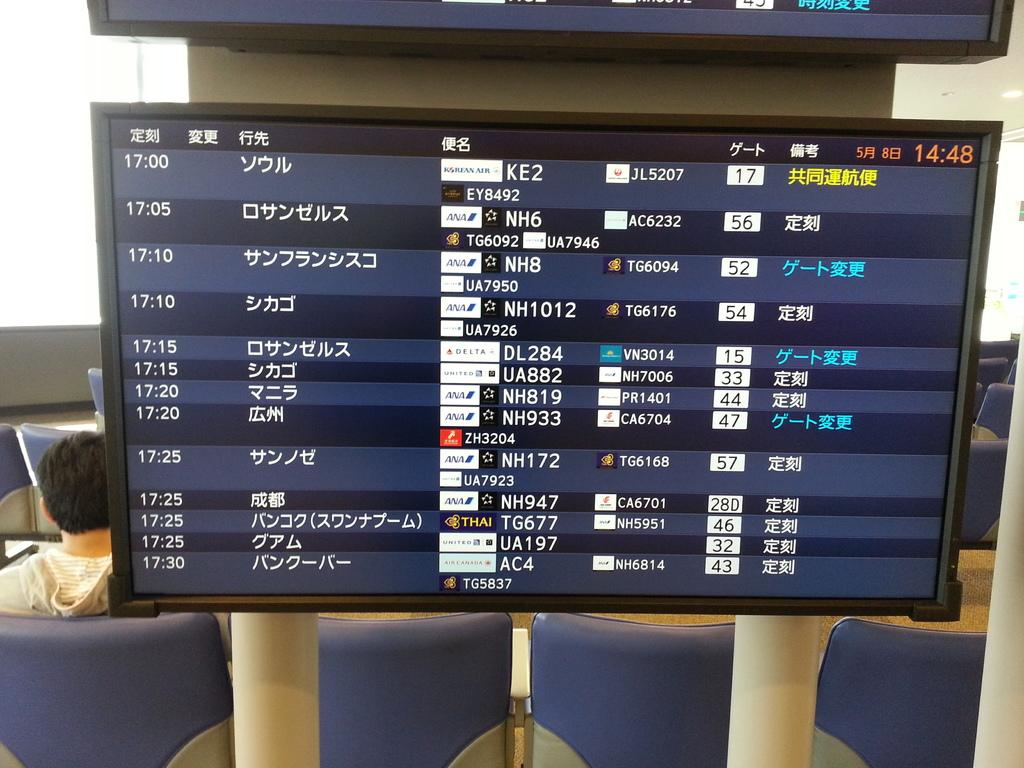What can be seen on the televisions in the picture? There are images on the televisions in the picture. What type of objects are present in the picture that support structures? There are poles in the picture. What type of furniture is visible in the picture? There are chairs in the picture. Who or what is present in the picture? There is a person in the picture. What is visible beneath the objects and people in the picture? The ground is visible in the picture. What type of barrier or divider is present in the picture? There is a wall in the picture. What type of reward is being given to the person in the picture? There is no indication of a reward being given in the picture; it only shows televisions, poles, chairs, a person, the ground, and a wall. What type of crack is visible on the wall in the picture? There is no crack visible on the wall in the picture; it appears to be a solid structure. 